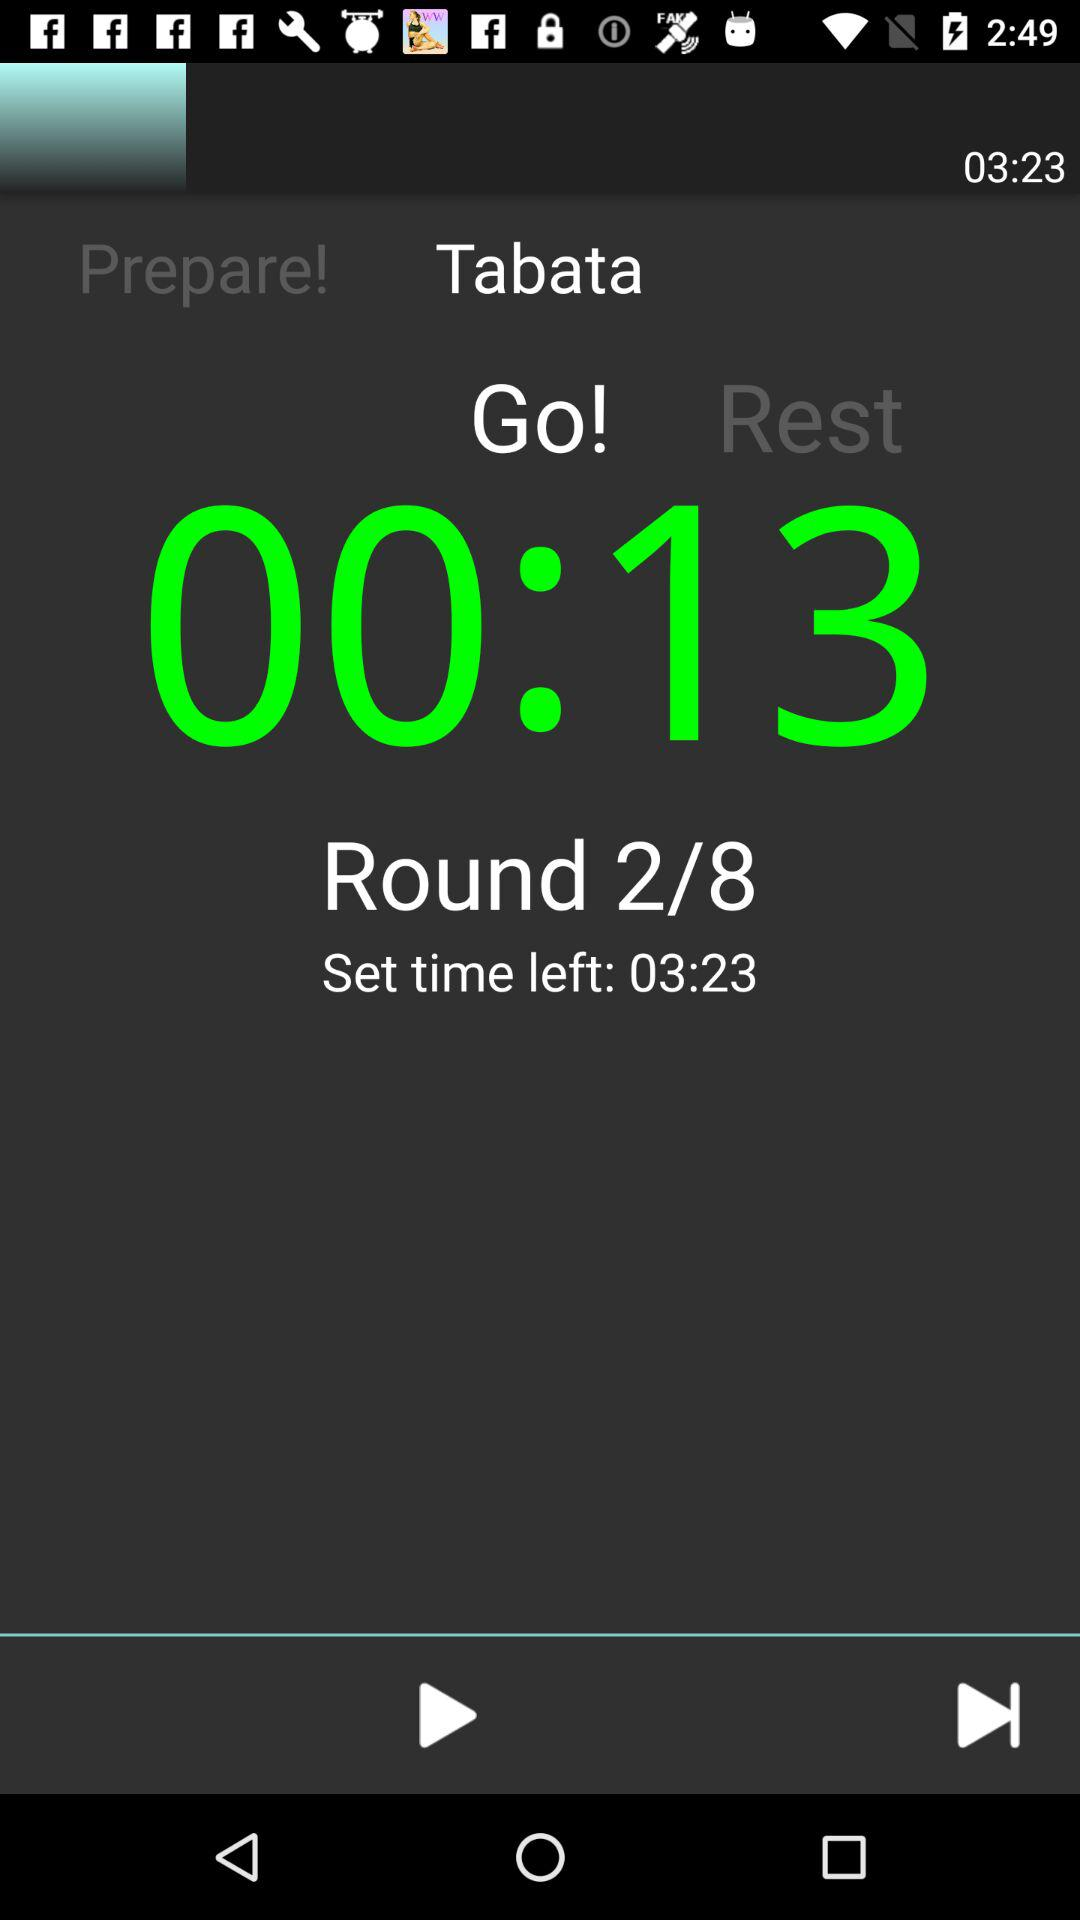How much set time is left? The left set time is 03:23. 